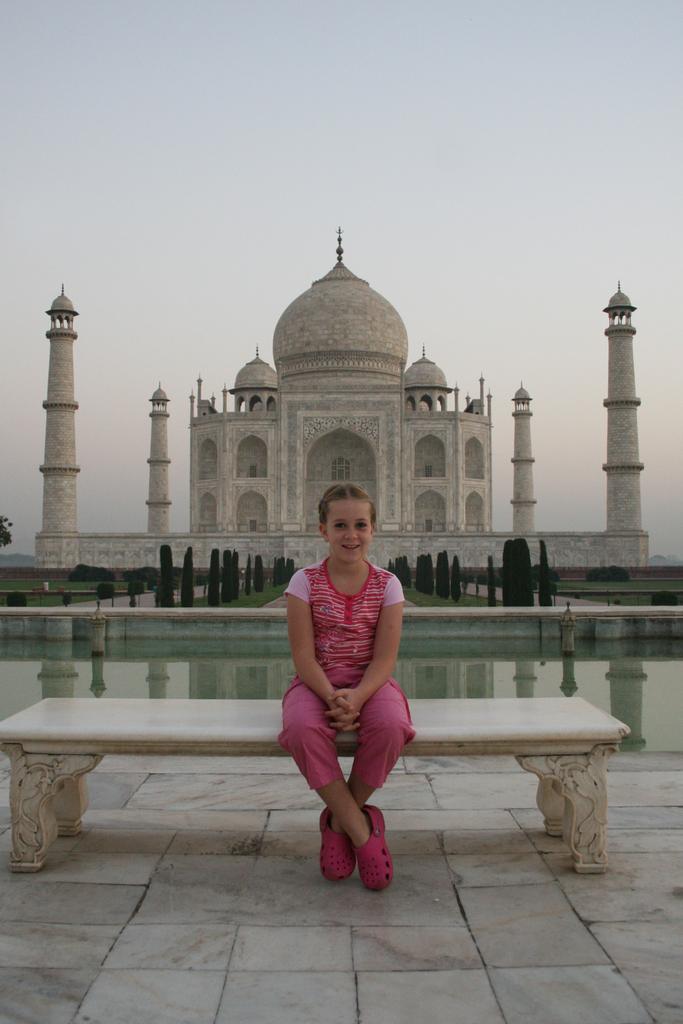Could you give a brief overview of what you see in this image? In this picture we can see a girl in the pink dress is sitting on a bench and behind the girl there is water, trees, Taj Mahal and a sky. 